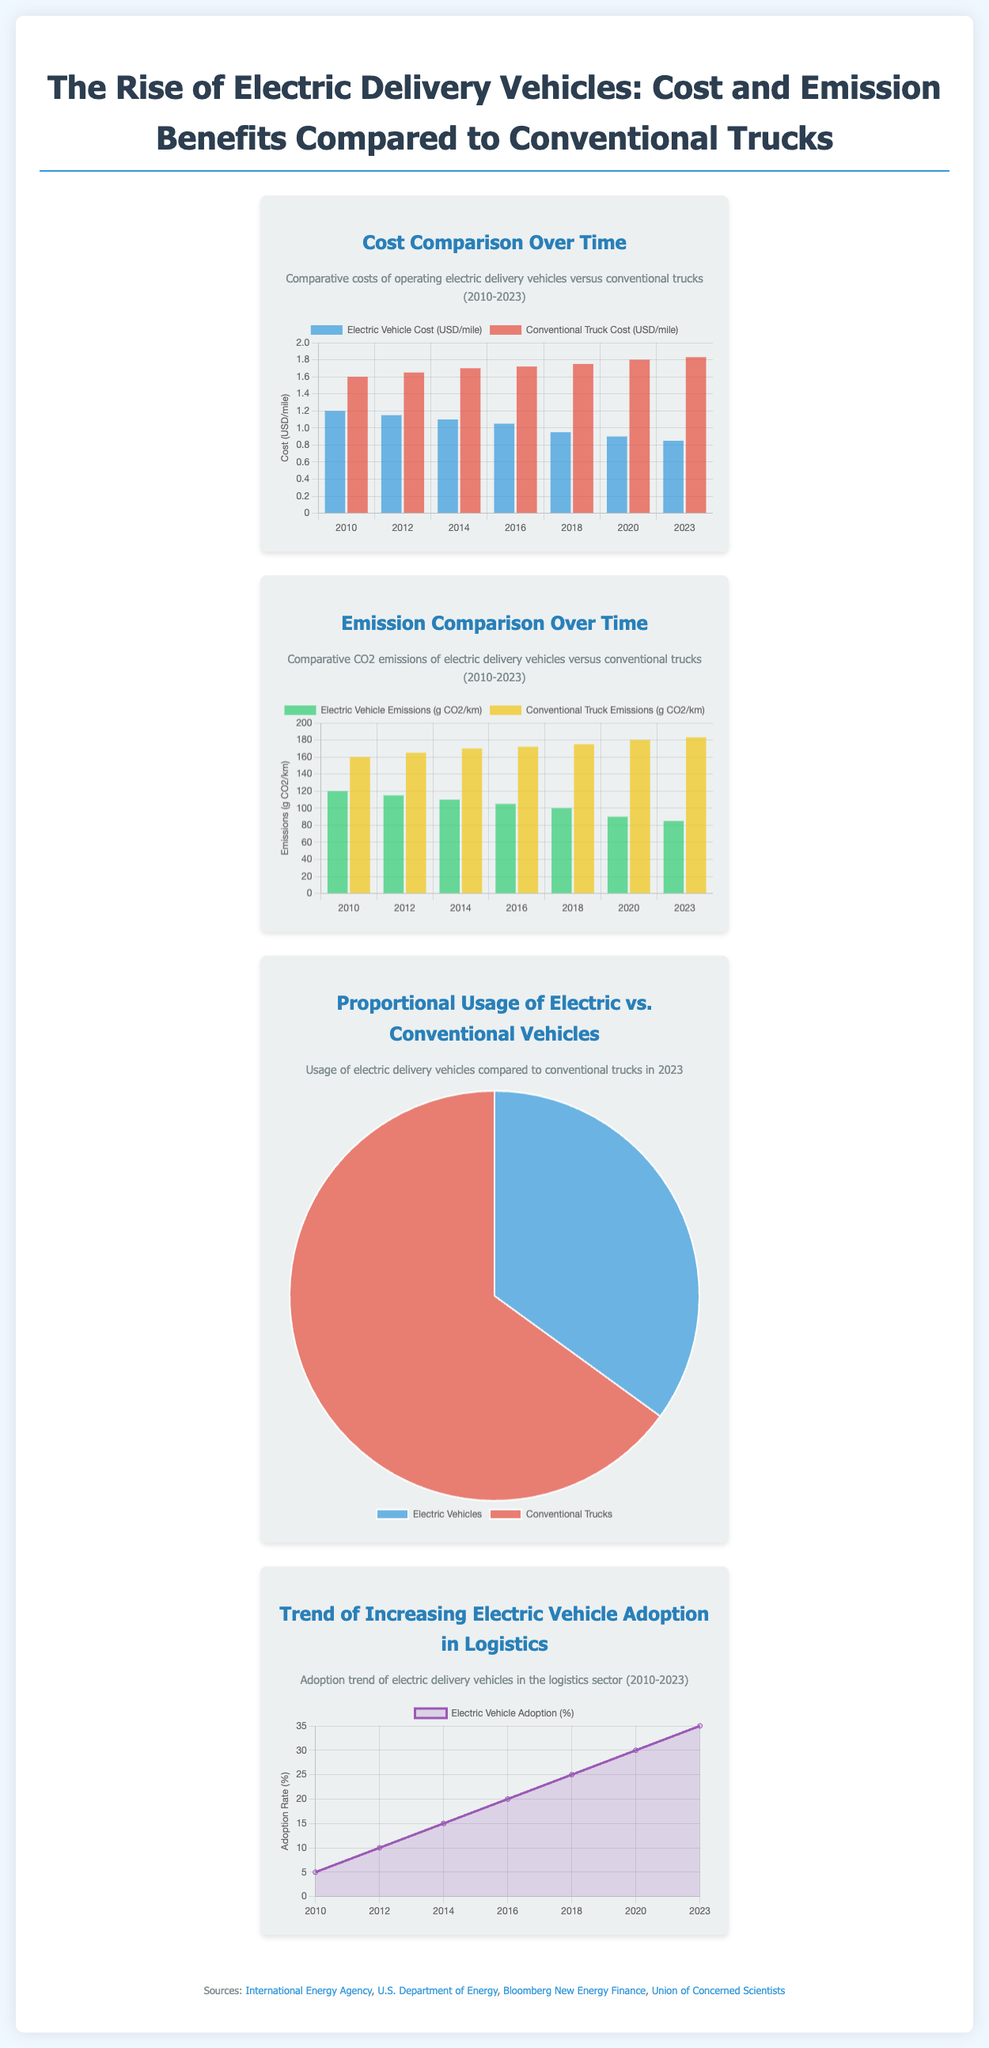what is the cost of electric vehicles per mile in 2023? The cost of electric vehicles per mile is detailed in the cost comparison chart for the year 2023, which shows $0.85.
Answer: $0.85 what is the emission level for electric vehicles in grams of CO2 per kilometer in 2023? The emission level for electric vehicles is shown in the emission comparison chart for 2023, which indicates 85 grams of CO2 per kilometer.
Answer: 85 grams what percentage of delivery vehicles were electric in 2023? The proportional usage of electric vs. conventional vehicles chart shows that 35% of delivery vehicles were electric in 2023.
Answer: 35% what was the adoption rate of electric vehicles in logistics in 2018? The trend of increasing electric vehicle adoption line chart indicates the adoption rate in 2018 was 25%.
Answer: 25% which category had higher costs in 2020? The cost comparison chart shows that conventional trucks had higher costs compared to electric vehicles in 2020.
Answer: Conventional trucks what was the trend in electric vehicle emissions from 2010 to 2023? The emission comparison chart demonstrates that electric vehicle emissions decreased from 120 grams in 2010 to 85 grams in 2023.
Answer: Decreased how many grams of CO2 per kilometer were emitted by conventional trucks in 2012? The emission comparison chart indicates that conventional trucks emitted 165 grams of CO2 per kilometer in 2012.
Answer: 165 grams what is the overall trend observed in the electric vehicle adoption rate from 2010 to 2023? The line chart for adoption trend illustrates an increasing trend in electric vehicle adoption from 5% in 2010 to 35% in 2023.
Answer: Increasing what color represents electric vehicles in the usage pie chart? In the proportional usage pie chart, the color representing electric vehicles is blue.
Answer: Blue 